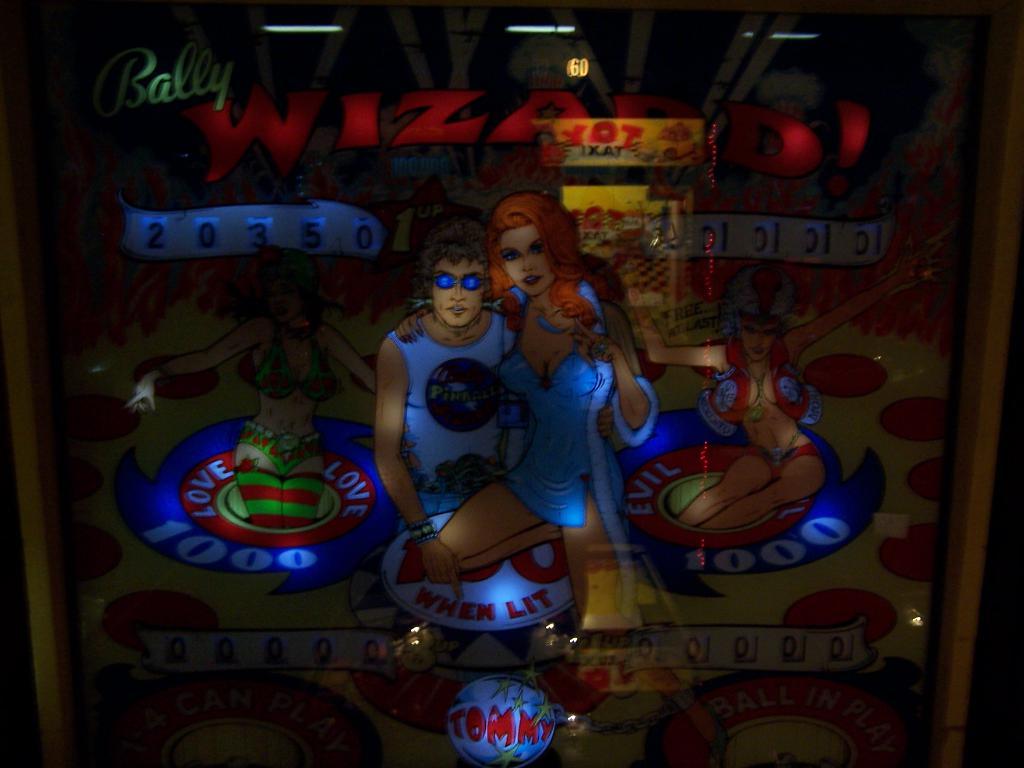What is the current high score of this pinball machine game?
Ensure brevity in your answer.  20350. 